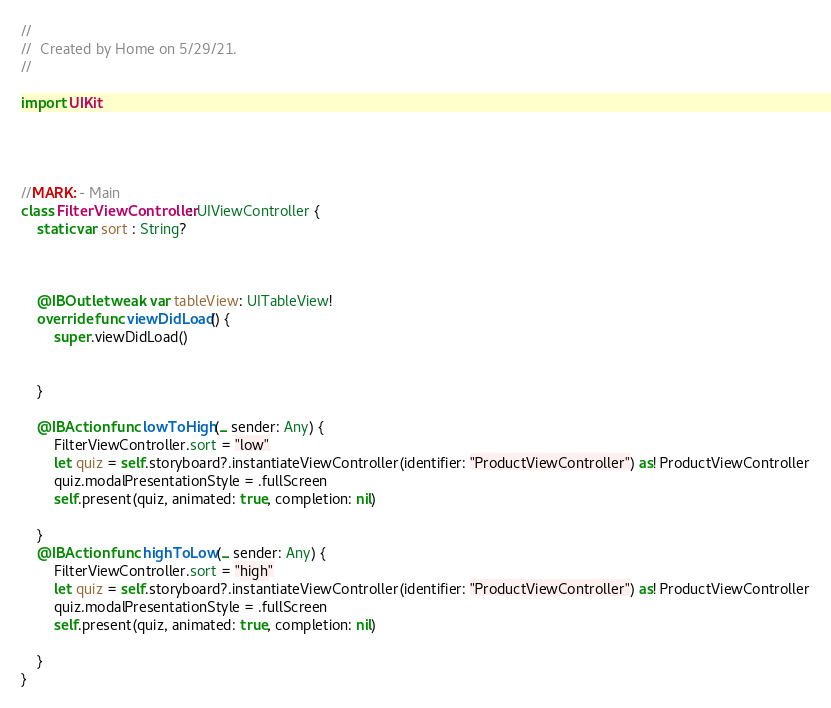<code> <loc_0><loc_0><loc_500><loc_500><_Swift_>//
//  Created by Home on 5/29/21.
//

import UIKit




//MARK: - Main
class FilterViewController: UIViewController {
    static var sort : String?
    
   
  
    @IBOutlet weak var tableView: UITableView!
    override func viewDidLoad() {
        super.viewDidLoad()
        
        
    }
    
    @IBAction func lowToHigh(_ sender: Any) {
        FilterViewController.sort = "low"
        let quiz = self.storyboard?.instantiateViewController(identifier: "ProductViewController") as! ProductViewController
        quiz.modalPresentationStyle = .fullScreen
        self.present(quiz, animated: true, completion: nil)
      
    }
    @IBAction func highToLow(_ sender: Any) {
        FilterViewController.sort = "high"
        let quiz = self.storyboard?.instantiateViewController(identifier: "ProductViewController") as! ProductViewController
        quiz.modalPresentationStyle = .fullScreen
        self.present(quiz, animated: true, completion: nil)
        
    }
}
</code> 